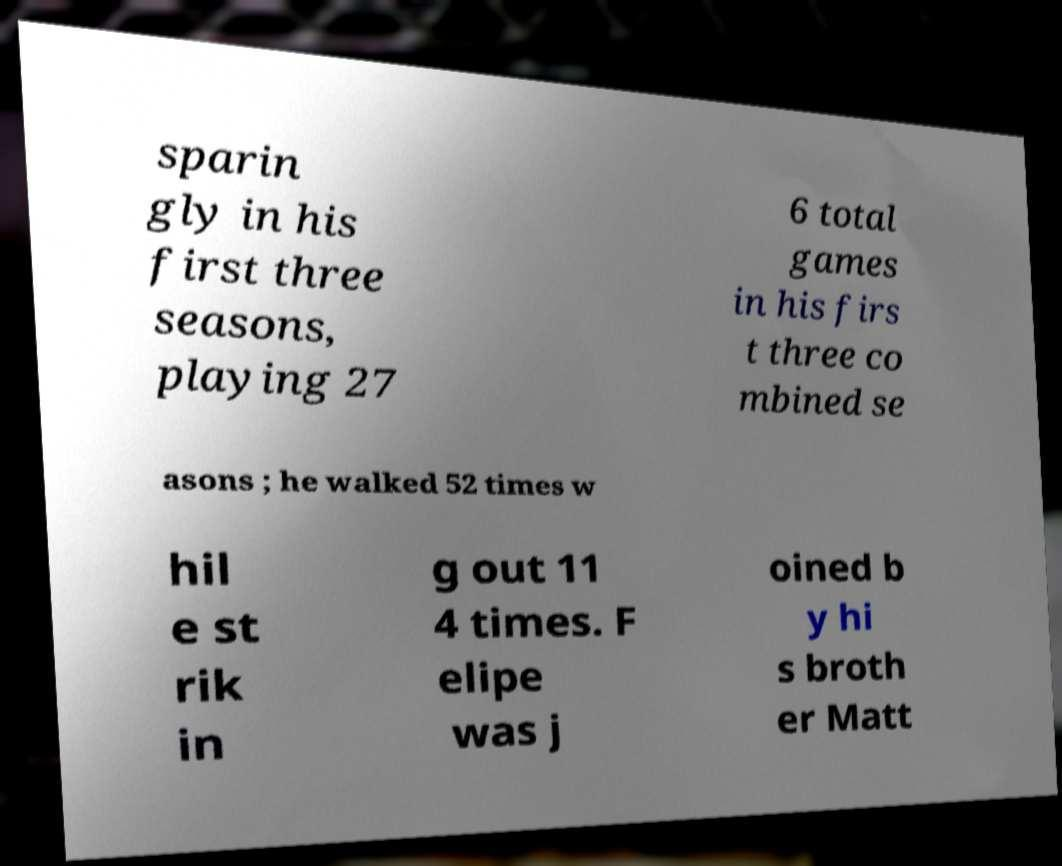Can you accurately transcribe the text from the provided image for me? sparin gly in his first three seasons, playing 27 6 total games in his firs t three co mbined se asons ; he walked 52 times w hil e st rik in g out 11 4 times. F elipe was j oined b y hi s broth er Matt 